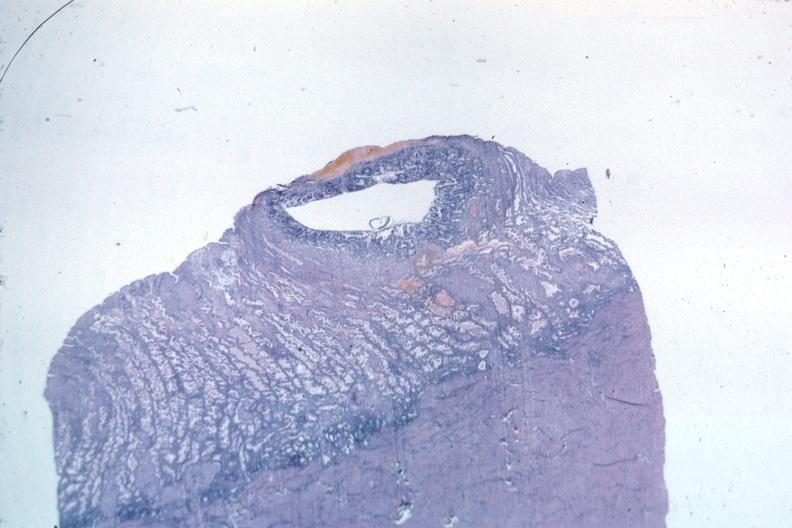s fetus developing very early present?
Answer the question using a single word or phrase. Yes 